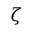<formula> <loc_0><loc_0><loc_500><loc_500>\zeta</formula> 